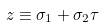<formula> <loc_0><loc_0><loc_500><loc_500>z \equiv \sigma _ { 1 } + \sigma _ { 2 } \tau</formula> 